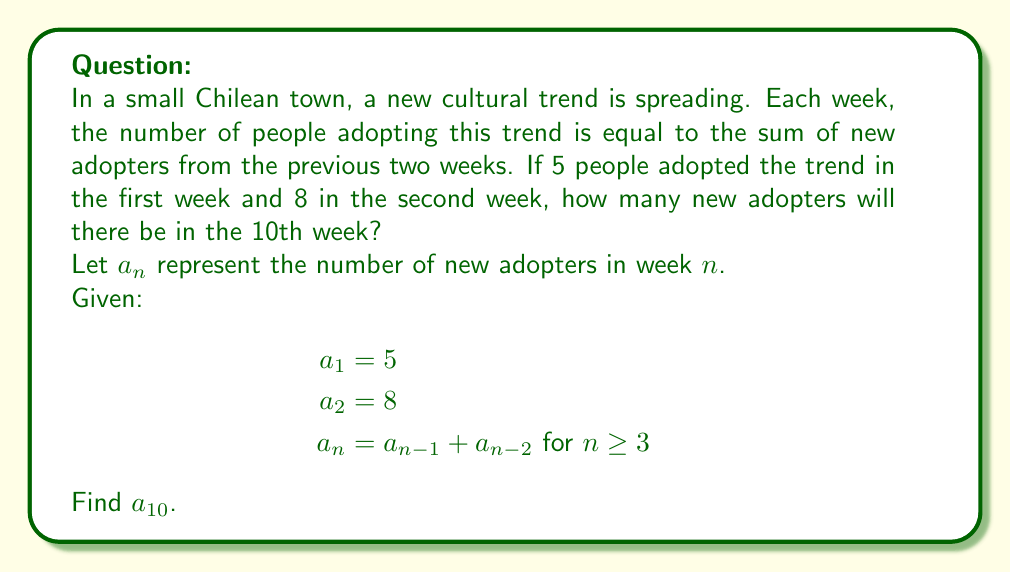Provide a solution to this math problem. To solve this problem, we need to use the given recurrence relation and initial conditions to calculate the number of new adopters for each week up to the 10th week.

Let's calculate step by step:

1) We're given $a_1 = 5$ and $a_2 = 8$

2) For $n \geq 3$, we use the recurrence relation $a_n = a_{n-1} + a_{n-2}$

3) Let's calculate for each week:

   $a_3 = a_2 + a_1 = 8 + 5 = 13$
   $a_4 = a_3 + a_2 = 13 + 8 = 21$
   $a_5 = a_4 + a_3 = 21 + 13 = 34$
   $a_6 = a_5 + a_4 = 34 + 21 = 55$
   $a_7 = a_6 + a_5 = 55 + 34 = 89$
   $a_8 = a_7 + a_6 = 89 + 55 = 144$
   $a_9 = a_8 + a_7 = 144 + 89 = 233$
   $a_{10} = a_9 + a_8 = 233 + 144 = 377$

Therefore, in the 10th week, there will be 377 new adopters of the cultural trend.

Note: This sequence is actually the famous Fibonacci sequence, which often appears in natural growth patterns.
Answer: 377 